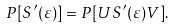Convert formula to latex. <formula><loc_0><loc_0><loc_500><loc_500>P [ S ^ { \prime } ( \varepsilon ) ] = P [ U S ^ { \prime } ( \varepsilon ) V ] .</formula> 